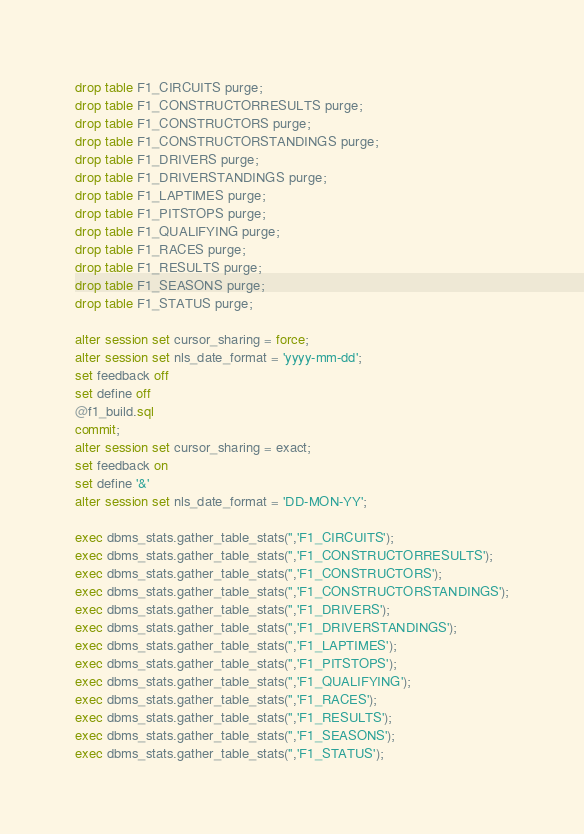<code> <loc_0><loc_0><loc_500><loc_500><_SQL_>drop table F1_CIRCUITS purge;
drop table F1_CONSTRUCTORRESULTS purge;
drop table F1_CONSTRUCTORS purge;
drop table F1_CONSTRUCTORSTANDINGS purge;
drop table F1_DRIVERS purge;
drop table F1_DRIVERSTANDINGS purge;
drop table F1_LAPTIMES purge;
drop table F1_PITSTOPS purge;
drop table F1_QUALIFYING purge;
drop table F1_RACES purge;
drop table F1_RESULTS purge;
drop table F1_SEASONS purge;
drop table F1_STATUS purge;

alter session set cursor_sharing = force;
alter session set nls_date_format = 'yyyy-mm-dd';
set feedback off
set define off
@f1_build.sql
commit;
alter session set cursor_sharing = exact;
set feedback on
set define '&'
alter session set nls_date_format = 'DD-MON-YY';

exec dbms_stats.gather_table_stats('','F1_CIRCUITS');
exec dbms_stats.gather_table_stats('','F1_CONSTRUCTORRESULTS');
exec dbms_stats.gather_table_stats('','F1_CONSTRUCTORS');
exec dbms_stats.gather_table_stats('','F1_CONSTRUCTORSTANDINGS');
exec dbms_stats.gather_table_stats('','F1_DRIVERS');
exec dbms_stats.gather_table_stats('','F1_DRIVERSTANDINGS');
exec dbms_stats.gather_table_stats('','F1_LAPTIMES');
exec dbms_stats.gather_table_stats('','F1_PITSTOPS');
exec dbms_stats.gather_table_stats('','F1_QUALIFYING');
exec dbms_stats.gather_table_stats('','F1_RACES');
exec dbms_stats.gather_table_stats('','F1_RESULTS');
exec dbms_stats.gather_table_stats('','F1_SEASONS');
exec dbms_stats.gather_table_stats('','F1_STATUS');
</code> 